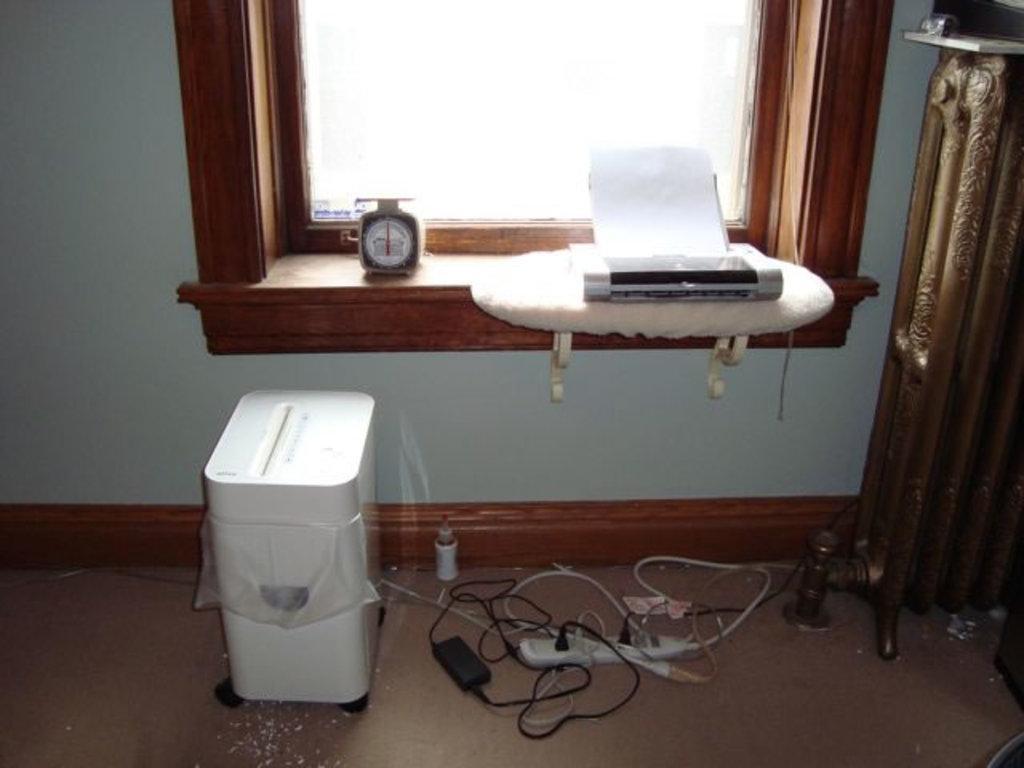Could you give a brief overview of what you see in this image? In this image we can see devices, paper, cables, extension box, floor, and few objects. In the background we can see wall and a window. 